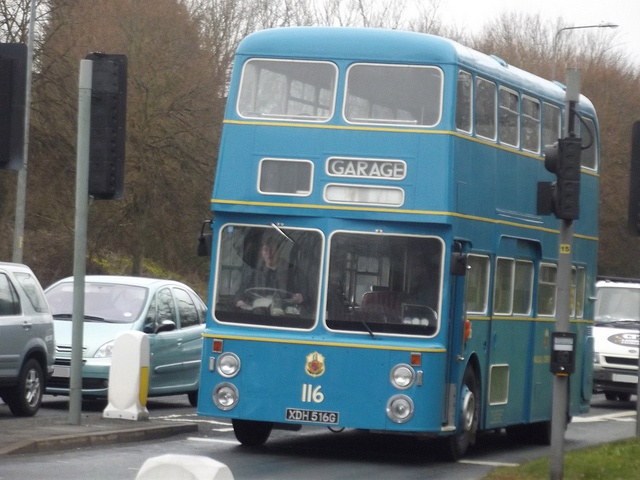Describe the objects in this image and their specific colors. I can see bus in gray, blue, teal, and darkgray tones, car in gray, lightgray, darkgray, and black tones, car in gray, black, lightgray, and darkgray tones, traffic light in gray and black tones, and car in gray, darkgray, white, and black tones in this image. 